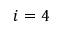<formula> <loc_0><loc_0><loc_500><loc_500>i = 4</formula> 